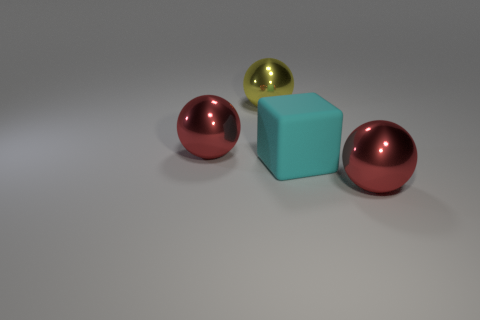Is there any other thing that has the same material as the large block?
Make the answer very short. No. What number of yellow objects have the same size as the rubber cube?
Make the answer very short. 1. What number of large matte cubes are left of the cyan block?
Make the answer very short. 0. Does the big yellow object have the same shape as the large object that is to the left of the yellow metal thing?
Provide a succinct answer. Yes. Is there a red object of the same shape as the large yellow metallic thing?
Your answer should be compact. Yes. What is the shape of the red shiny object that is on the left side of the red ball that is on the right side of the big block?
Offer a very short reply. Sphere. There is a large cyan rubber object that is in front of the yellow ball; what is its shape?
Your answer should be very brief. Cube. Do the shiny ball left of the yellow object and the thing to the right of the cube have the same color?
Ensure brevity in your answer.  Yes. What number of big objects are both left of the matte block and in front of the yellow metallic ball?
Offer a very short reply. 1. The cyan rubber cube has what size?
Provide a short and direct response. Large. 